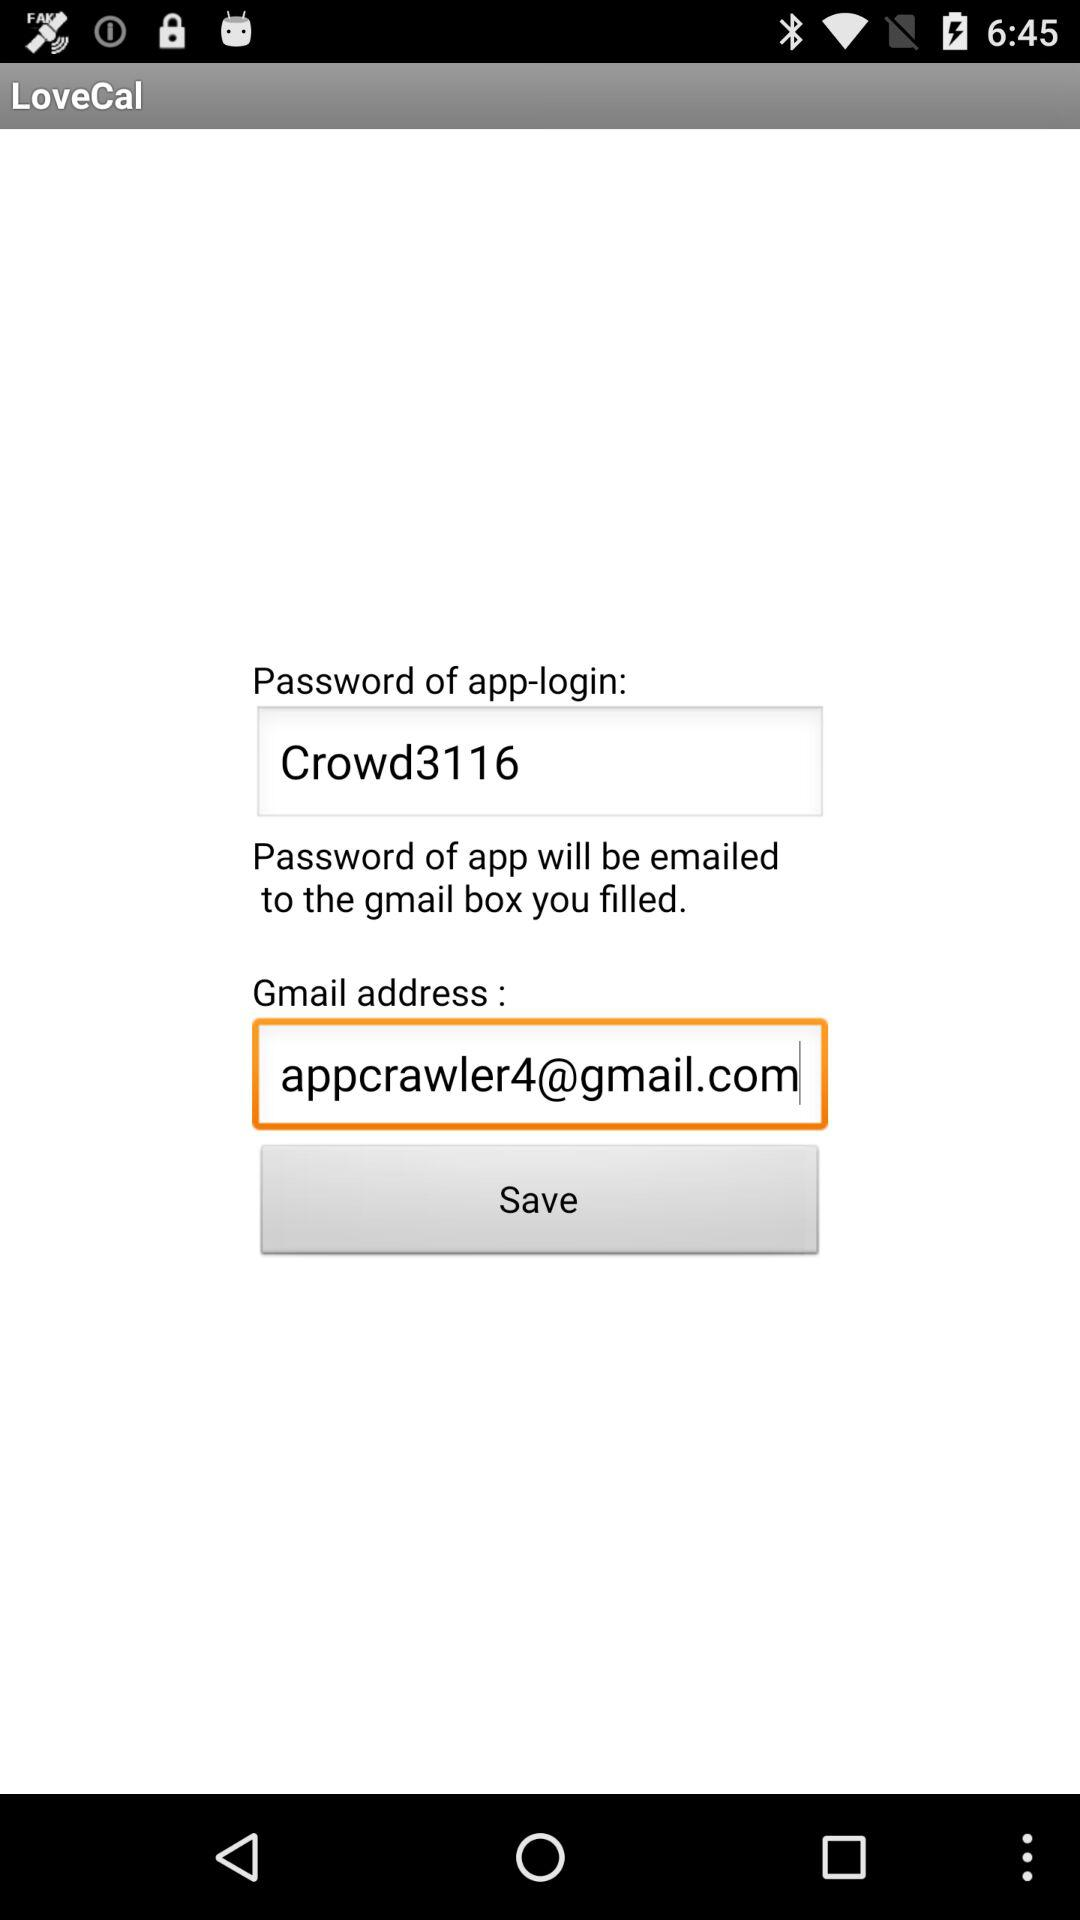What is the Gmail address of the user? The Gmail address of the user is appcrawler4@gmail.com. 